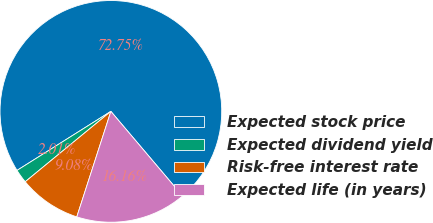<chart> <loc_0><loc_0><loc_500><loc_500><pie_chart><fcel>Expected stock price<fcel>Expected dividend yield<fcel>Risk-free interest rate<fcel>Expected life (in years)<nl><fcel>72.75%<fcel>2.01%<fcel>9.08%<fcel>16.16%<nl></chart> 